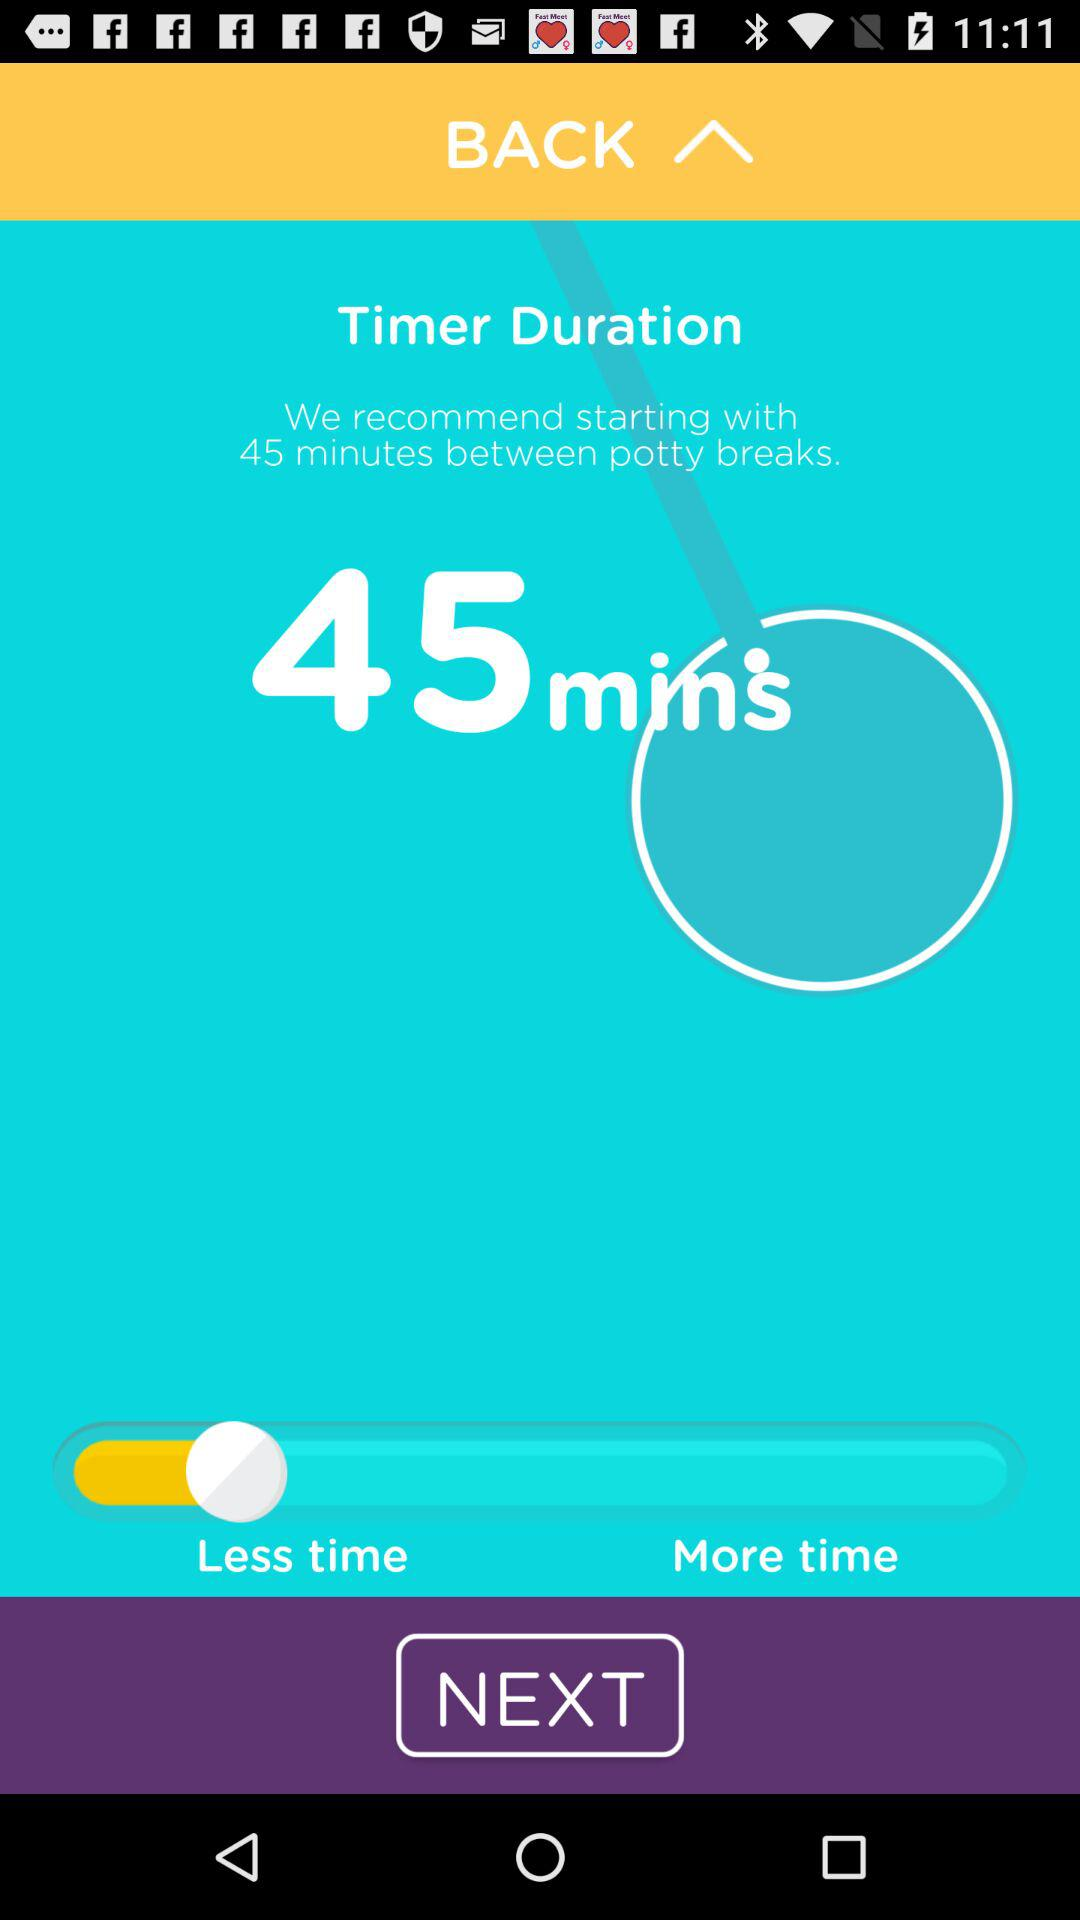What is the name of the application? The name of the application shown in the image is not directly visible or mentioned in the user interface presented. However, based on the function and aesthetic elements, it could potentially be an app related to time management, productivity, or a specialized tool like a potty training scheduler. For an accurate identification, further context or a view of the app's name or icon in the device's app menu would be necessary. 